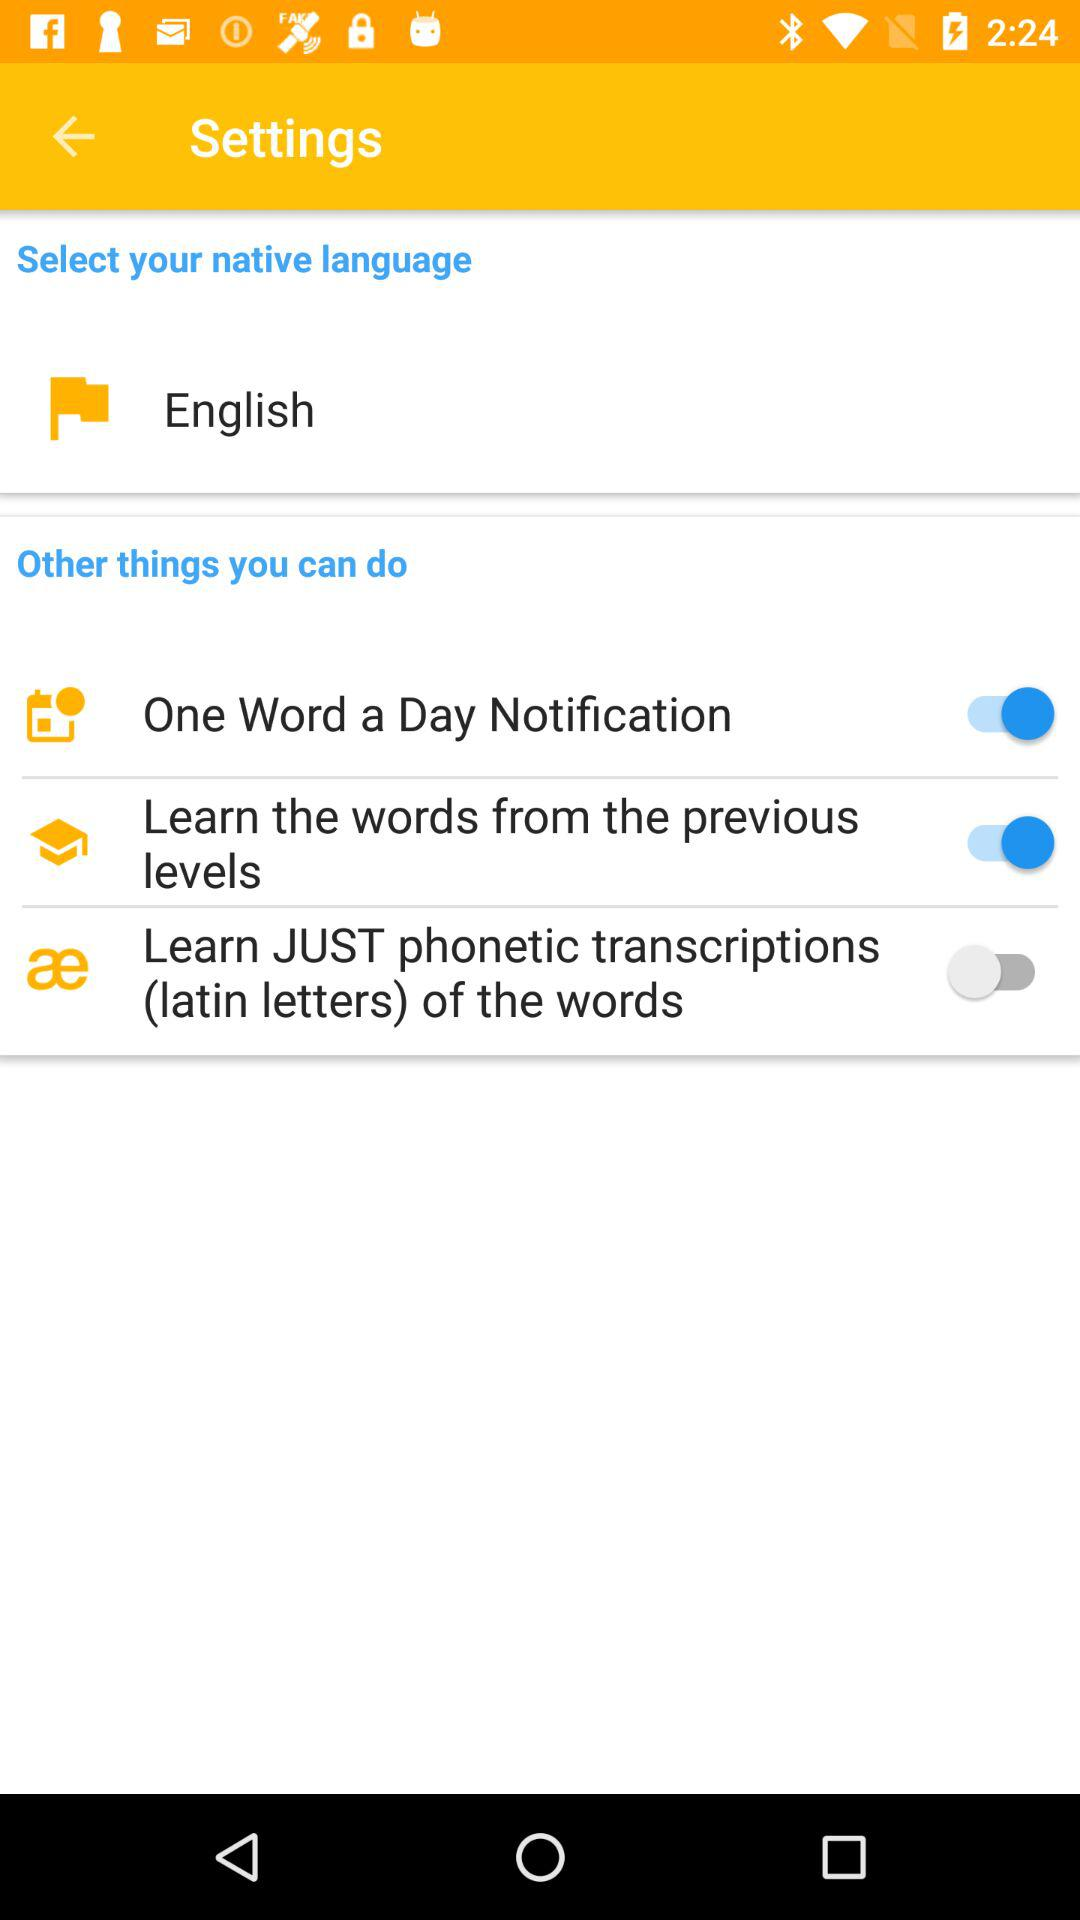Which settings are on? The on settings are "One Word a Day Notification" and "Learn the words from the previous levels". 